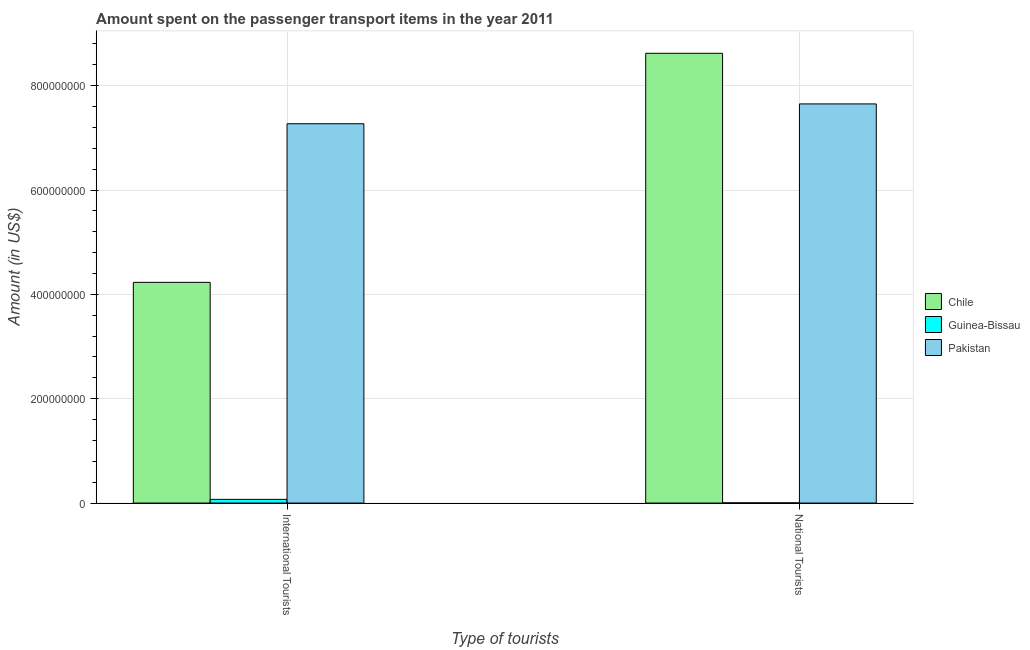How many groups of bars are there?
Keep it short and to the point. 2. Are the number of bars on each tick of the X-axis equal?
Make the answer very short. Yes. How many bars are there on the 1st tick from the left?
Your response must be concise. 3. How many bars are there on the 1st tick from the right?
Provide a short and direct response. 3. What is the label of the 2nd group of bars from the left?
Ensure brevity in your answer.  National Tourists. What is the amount spent on transport items of international tourists in Pakistan?
Ensure brevity in your answer.  7.27e+08. Across all countries, what is the maximum amount spent on transport items of national tourists?
Your response must be concise. 8.62e+08. Across all countries, what is the minimum amount spent on transport items of national tourists?
Give a very brief answer. 4.00e+05. In which country was the amount spent on transport items of national tourists maximum?
Give a very brief answer. Chile. In which country was the amount spent on transport items of national tourists minimum?
Provide a succinct answer. Guinea-Bissau. What is the total amount spent on transport items of international tourists in the graph?
Make the answer very short. 1.16e+09. What is the difference between the amount spent on transport items of national tourists in Chile and that in Guinea-Bissau?
Offer a terse response. 8.62e+08. What is the difference between the amount spent on transport items of international tourists in Chile and the amount spent on transport items of national tourists in Pakistan?
Provide a short and direct response. -3.42e+08. What is the average amount spent on transport items of international tourists per country?
Provide a succinct answer. 3.86e+08. What is the difference between the amount spent on transport items of national tourists and amount spent on transport items of international tourists in Guinea-Bissau?
Your response must be concise. -6.70e+06. In how many countries, is the amount spent on transport items of international tourists greater than 600000000 US$?
Offer a very short reply. 1. What is the ratio of the amount spent on transport items of national tourists in Guinea-Bissau to that in Chile?
Your answer should be compact. 0. Is the amount spent on transport items of international tourists in Guinea-Bissau less than that in Chile?
Give a very brief answer. Yes. In how many countries, is the amount spent on transport items of international tourists greater than the average amount spent on transport items of international tourists taken over all countries?
Keep it short and to the point. 2. What does the 2nd bar from the left in National Tourists represents?
Give a very brief answer. Guinea-Bissau. What does the 3rd bar from the right in National Tourists represents?
Give a very brief answer. Chile. How many countries are there in the graph?
Your response must be concise. 3. Does the graph contain any zero values?
Ensure brevity in your answer.  No. Does the graph contain grids?
Offer a very short reply. Yes. How many legend labels are there?
Provide a short and direct response. 3. How are the legend labels stacked?
Your answer should be compact. Vertical. What is the title of the graph?
Your response must be concise. Amount spent on the passenger transport items in the year 2011. Does "Europe(developing only)" appear as one of the legend labels in the graph?
Offer a very short reply. No. What is the label or title of the X-axis?
Make the answer very short. Type of tourists. What is the Amount (in US$) of Chile in International Tourists?
Your answer should be very brief. 4.23e+08. What is the Amount (in US$) of Guinea-Bissau in International Tourists?
Keep it short and to the point. 7.10e+06. What is the Amount (in US$) of Pakistan in International Tourists?
Offer a very short reply. 7.27e+08. What is the Amount (in US$) in Chile in National Tourists?
Your answer should be very brief. 8.62e+08. What is the Amount (in US$) of Guinea-Bissau in National Tourists?
Offer a very short reply. 4.00e+05. What is the Amount (in US$) of Pakistan in National Tourists?
Make the answer very short. 7.65e+08. Across all Type of tourists, what is the maximum Amount (in US$) of Chile?
Your answer should be compact. 8.62e+08. Across all Type of tourists, what is the maximum Amount (in US$) in Guinea-Bissau?
Provide a succinct answer. 7.10e+06. Across all Type of tourists, what is the maximum Amount (in US$) of Pakistan?
Offer a terse response. 7.65e+08. Across all Type of tourists, what is the minimum Amount (in US$) of Chile?
Ensure brevity in your answer.  4.23e+08. Across all Type of tourists, what is the minimum Amount (in US$) in Pakistan?
Offer a terse response. 7.27e+08. What is the total Amount (in US$) of Chile in the graph?
Offer a terse response. 1.28e+09. What is the total Amount (in US$) of Guinea-Bissau in the graph?
Keep it short and to the point. 7.50e+06. What is the total Amount (in US$) of Pakistan in the graph?
Your response must be concise. 1.49e+09. What is the difference between the Amount (in US$) of Chile in International Tourists and that in National Tourists?
Offer a terse response. -4.39e+08. What is the difference between the Amount (in US$) in Guinea-Bissau in International Tourists and that in National Tourists?
Keep it short and to the point. 6.70e+06. What is the difference between the Amount (in US$) in Pakistan in International Tourists and that in National Tourists?
Your answer should be very brief. -3.80e+07. What is the difference between the Amount (in US$) in Chile in International Tourists and the Amount (in US$) in Guinea-Bissau in National Tourists?
Give a very brief answer. 4.23e+08. What is the difference between the Amount (in US$) in Chile in International Tourists and the Amount (in US$) in Pakistan in National Tourists?
Offer a terse response. -3.42e+08. What is the difference between the Amount (in US$) of Guinea-Bissau in International Tourists and the Amount (in US$) of Pakistan in National Tourists?
Make the answer very short. -7.58e+08. What is the average Amount (in US$) in Chile per Type of tourists?
Keep it short and to the point. 6.42e+08. What is the average Amount (in US$) of Guinea-Bissau per Type of tourists?
Ensure brevity in your answer.  3.75e+06. What is the average Amount (in US$) in Pakistan per Type of tourists?
Give a very brief answer. 7.46e+08. What is the difference between the Amount (in US$) of Chile and Amount (in US$) of Guinea-Bissau in International Tourists?
Provide a succinct answer. 4.16e+08. What is the difference between the Amount (in US$) in Chile and Amount (in US$) in Pakistan in International Tourists?
Offer a terse response. -3.04e+08. What is the difference between the Amount (in US$) of Guinea-Bissau and Amount (in US$) of Pakistan in International Tourists?
Ensure brevity in your answer.  -7.20e+08. What is the difference between the Amount (in US$) of Chile and Amount (in US$) of Guinea-Bissau in National Tourists?
Make the answer very short. 8.62e+08. What is the difference between the Amount (in US$) of Chile and Amount (in US$) of Pakistan in National Tourists?
Provide a succinct answer. 9.70e+07. What is the difference between the Amount (in US$) in Guinea-Bissau and Amount (in US$) in Pakistan in National Tourists?
Provide a succinct answer. -7.65e+08. What is the ratio of the Amount (in US$) in Chile in International Tourists to that in National Tourists?
Keep it short and to the point. 0.49. What is the ratio of the Amount (in US$) of Guinea-Bissau in International Tourists to that in National Tourists?
Keep it short and to the point. 17.75. What is the ratio of the Amount (in US$) of Pakistan in International Tourists to that in National Tourists?
Your answer should be compact. 0.95. What is the difference between the highest and the second highest Amount (in US$) of Chile?
Ensure brevity in your answer.  4.39e+08. What is the difference between the highest and the second highest Amount (in US$) in Guinea-Bissau?
Your answer should be very brief. 6.70e+06. What is the difference between the highest and the second highest Amount (in US$) in Pakistan?
Provide a succinct answer. 3.80e+07. What is the difference between the highest and the lowest Amount (in US$) in Chile?
Ensure brevity in your answer.  4.39e+08. What is the difference between the highest and the lowest Amount (in US$) of Guinea-Bissau?
Provide a succinct answer. 6.70e+06. What is the difference between the highest and the lowest Amount (in US$) in Pakistan?
Ensure brevity in your answer.  3.80e+07. 